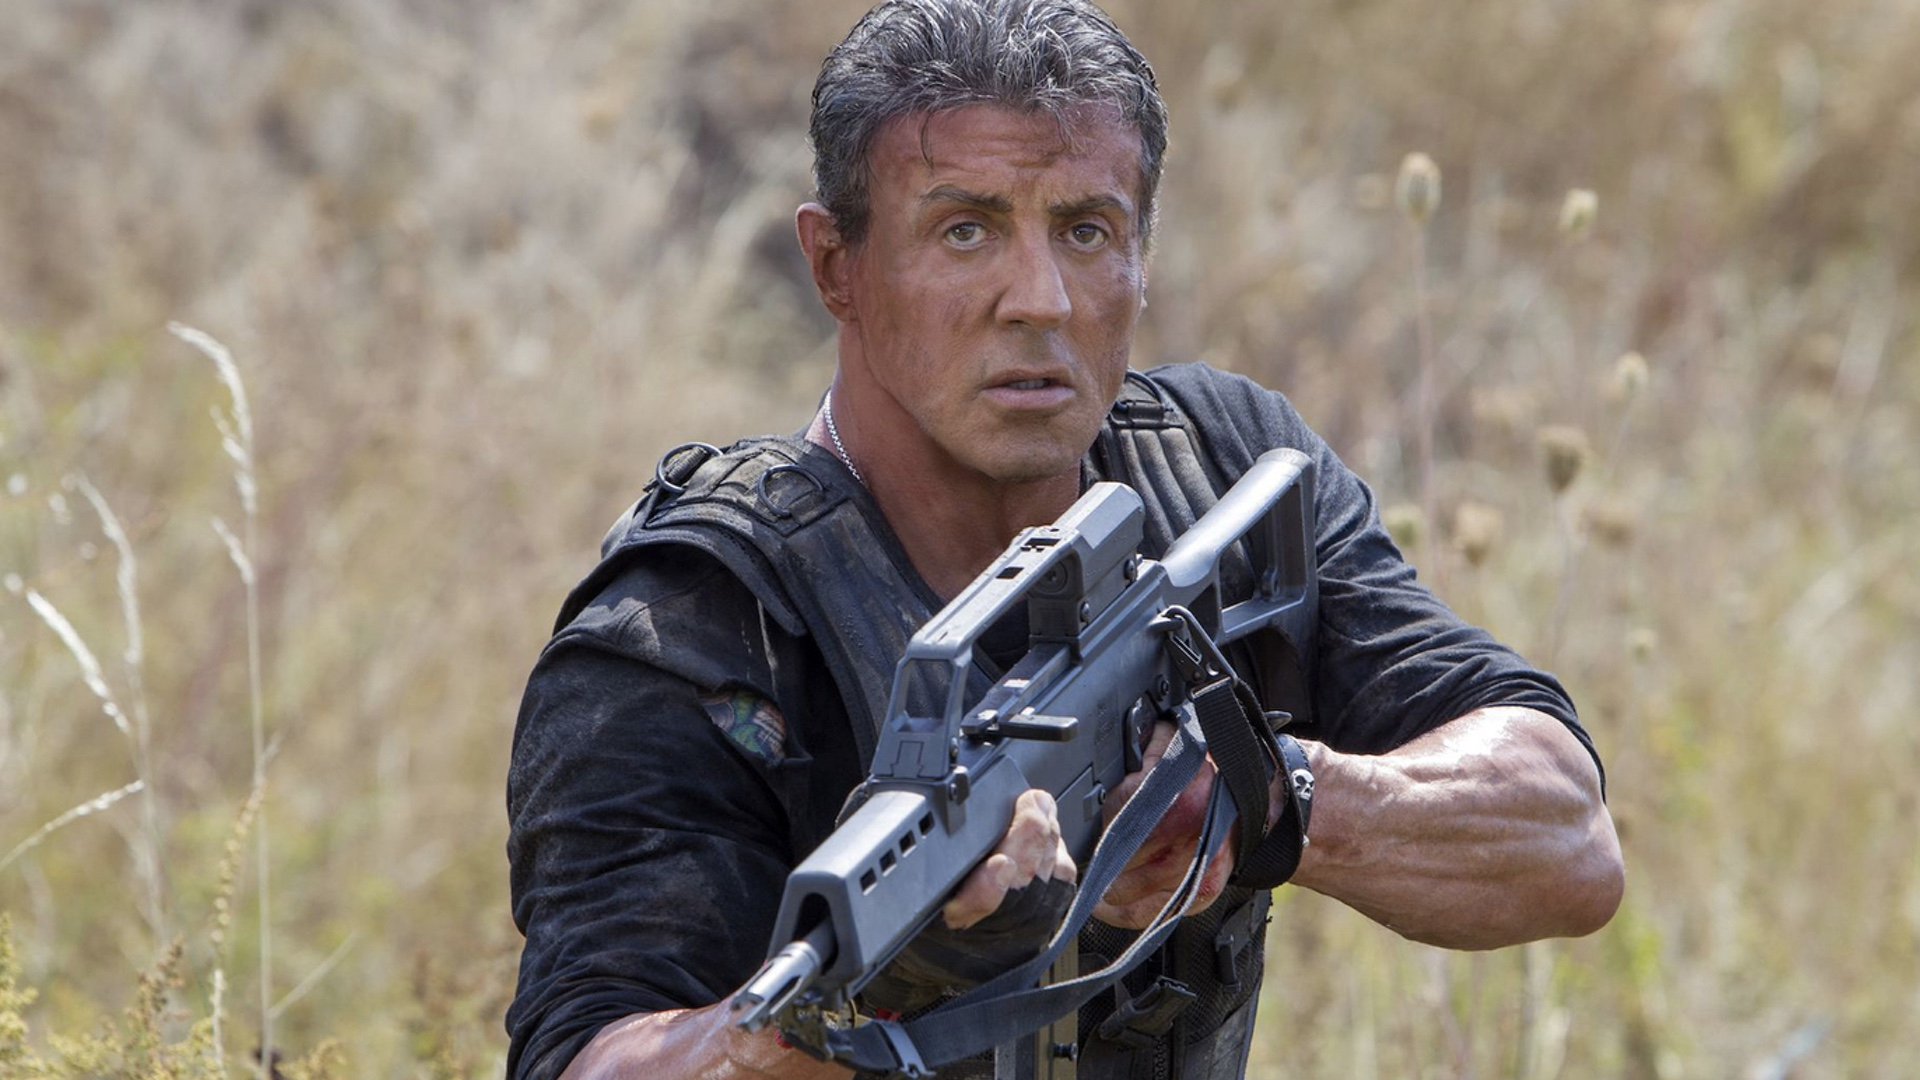What kind of story do you imagine this scene is depicting? This scene could be illustrating the beginning of a climactic moment in an action-packed story. The character seems to be in the midst of a mission, perhaps scouting for enemies or preparing for an imminent threat. His intense expression and firm grip on the gun suggest he is in a highly dangerous situation where every second counts. How do you think this character is feeling and why? The character appears to be feeling a mix of determination and anxiety. His serious expression and the tension in his posture indicate that he is highly focused and ready to act at a moment's notice. This mindset is likely driven by the perilous circumstances he finds himself in, requiring him to stay alert and prepared for any threat. What could be the outcome of this situation? The outcome of this situation could vary widely. The character might successfully complete his mission after a dramatic confrontation, or he could face a significant setback forcing him to adapt and regroup. The tension in the image suggests a thrilling storyline with unexpected twists. 